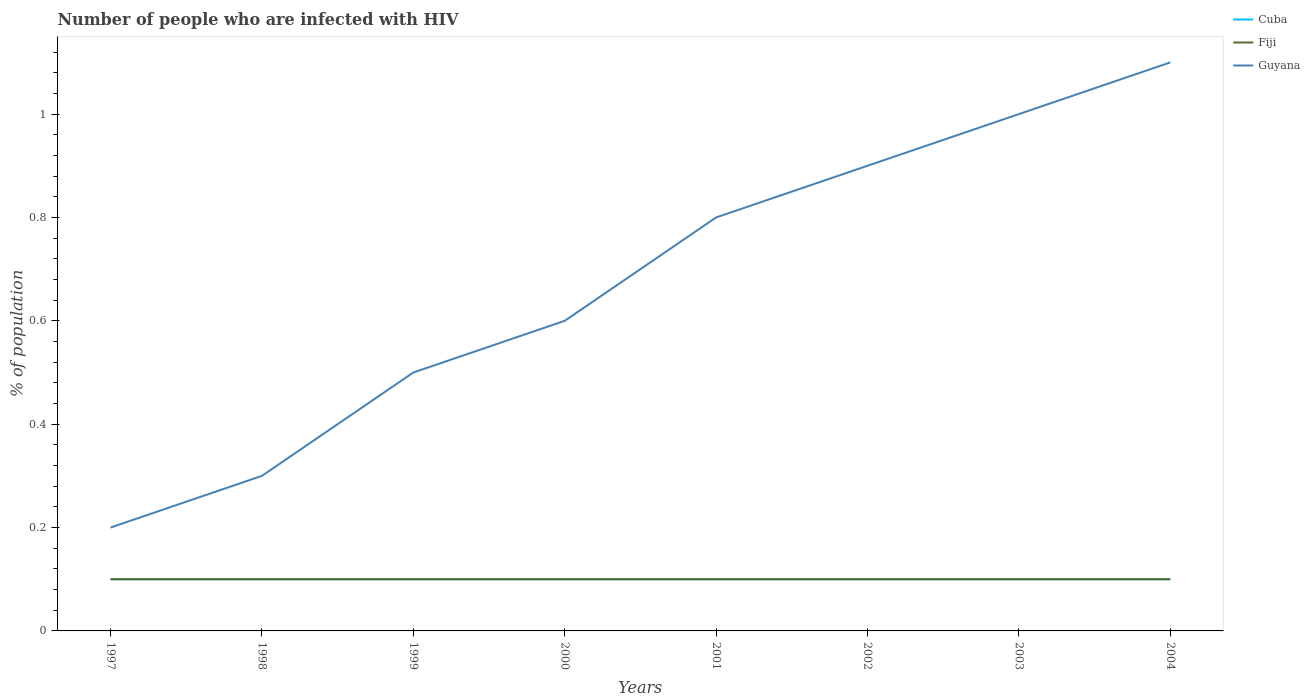How many different coloured lines are there?
Offer a very short reply. 3. Is the number of lines equal to the number of legend labels?
Provide a short and direct response. Yes. In which year was the percentage of HIV infected population in in Cuba maximum?
Ensure brevity in your answer.  1997. What is the difference between the highest and the second highest percentage of HIV infected population in in Guyana?
Ensure brevity in your answer.  0.9. What is the difference between the highest and the lowest percentage of HIV infected population in in Fiji?
Your answer should be very brief. 0. Is the percentage of HIV infected population in in Cuba strictly greater than the percentage of HIV infected population in in Fiji over the years?
Your answer should be very brief. No. Does the graph contain grids?
Offer a very short reply. No. Where does the legend appear in the graph?
Your answer should be compact. Top right. How many legend labels are there?
Your answer should be very brief. 3. How are the legend labels stacked?
Give a very brief answer. Vertical. What is the title of the graph?
Offer a terse response. Number of people who are infected with HIV. What is the label or title of the X-axis?
Keep it short and to the point. Years. What is the label or title of the Y-axis?
Make the answer very short. % of population. What is the % of population in Guyana in 1997?
Ensure brevity in your answer.  0.2. What is the % of population of Cuba in 1998?
Offer a terse response. 0.1. What is the % of population of Fiji in 1998?
Offer a very short reply. 0.1. What is the % of population of Guyana in 1998?
Give a very brief answer. 0.3. What is the % of population of Cuba in 2000?
Provide a succinct answer. 0.1. What is the % of population of Guyana in 2000?
Your answer should be very brief. 0.6. What is the % of population of Guyana in 2001?
Ensure brevity in your answer.  0.8. What is the % of population in Cuba in 2003?
Keep it short and to the point. 0.1. What is the % of population in Fiji in 2003?
Offer a very short reply. 0.1. What is the % of population in Guyana in 2003?
Your answer should be compact. 1. Across all years, what is the maximum % of population of Cuba?
Offer a terse response. 0.1. Across all years, what is the maximum % of population in Fiji?
Keep it short and to the point. 0.1. Across all years, what is the maximum % of population in Guyana?
Make the answer very short. 1.1. Across all years, what is the minimum % of population of Cuba?
Offer a terse response. 0.1. Across all years, what is the minimum % of population of Fiji?
Ensure brevity in your answer.  0.1. What is the total % of population in Cuba in the graph?
Offer a terse response. 0.8. What is the total % of population of Guyana in the graph?
Provide a short and direct response. 5.4. What is the difference between the % of population in Cuba in 1997 and that in 1998?
Your response must be concise. 0. What is the difference between the % of population of Guyana in 1997 and that in 1998?
Your answer should be very brief. -0.1. What is the difference between the % of population in Cuba in 1997 and that in 1999?
Give a very brief answer. 0. What is the difference between the % of population of Fiji in 1997 and that in 1999?
Keep it short and to the point. 0. What is the difference between the % of population of Guyana in 1997 and that in 1999?
Keep it short and to the point. -0.3. What is the difference between the % of population in Guyana in 1997 and that in 2000?
Your answer should be compact. -0.4. What is the difference between the % of population of Cuba in 1997 and that in 2001?
Give a very brief answer. 0. What is the difference between the % of population of Guyana in 1997 and that in 2001?
Provide a succinct answer. -0.6. What is the difference between the % of population of Cuba in 1997 and that in 2002?
Provide a short and direct response. 0. What is the difference between the % of population of Guyana in 1997 and that in 2002?
Your response must be concise. -0.7. What is the difference between the % of population of Cuba in 1997 and that in 2003?
Offer a terse response. 0. What is the difference between the % of population in Cuba in 1997 and that in 2004?
Your answer should be very brief. 0. What is the difference between the % of population in Fiji in 1997 and that in 2004?
Make the answer very short. 0. What is the difference between the % of population in Guyana in 1997 and that in 2004?
Make the answer very short. -0.9. What is the difference between the % of population in Fiji in 1998 and that in 1999?
Ensure brevity in your answer.  0. What is the difference between the % of population of Guyana in 1998 and that in 1999?
Offer a very short reply. -0.2. What is the difference between the % of population in Cuba in 1998 and that in 2000?
Your response must be concise. 0. What is the difference between the % of population in Fiji in 1998 and that in 2000?
Make the answer very short. 0. What is the difference between the % of population in Fiji in 1998 and that in 2001?
Keep it short and to the point. 0. What is the difference between the % of population in Guyana in 1998 and that in 2001?
Your response must be concise. -0.5. What is the difference between the % of population in Guyana in 1998 and that in 2002?
Your response must be concise. -0.6. What is the difference between the % of population of Cuba in 1998 and that in 2003?
Make the answer very short. 0. What is the difference between the % of population of Fiji in 1998 and that in 2003?
Provide a succinct answer. 0. What is the difference between the % of population of Guyana in 1998 and that in 2003?
Give a very brief answer. -0.7. What is the difference between the % of population in Cuba in 1998 and that in 2004?
Offer a terse response. 0. What is the difference between the % of population of Fiji in 1998 and that in 2004?
Offer a very short reply. 0. What is the difference between the % of population in Guyana in 1998 and that in 2004?
Your answer should be compact. -0.8. What is the difference between the % of population in Guyana in 1999 and that in 2001?
Give a very brief answer. -0.3. What is the difference between the % of population in Guyana in 1999 and that in 2002?
Provide a succinct answer. -0.4. What is the difference between the % of population in Cuba in 1999 and that in 2003?
Make the answer very short. 0. What is the difference between the % of population in Fiji in 1999 and that in 2003?
Offer a terse response. 0. What is the difference between the % of population in Guyana in 1999 and that in 2003?
Provide a succinct answer. -0.5. What is the difference between the % of population of Guyana in 1999 and that in 2004?
Your answer should be compact. -0.6. What is the difference between the % of population in Cuba in 2000 and that in 2001?
Provide a succinct answer. 0. What is the difference between the % of population in Fiji in 2000 and that in 2001?
Ensure brevity in your answer.  0. What is the difference between the % of population of Fiji in 2000 and that in 2002?
Offer a very short reply. 0. What is the difference between the % of population in Guyana in 2000 and that in 2002?
Provide a short and direct response. -0.3. What is the difference between the % of population in Guyana in 2000 and that in 2003?
Keep it short and to the point. -0.4. What is the difference between the % of population of Fiji in 2000 and that in 2004?
Make the answer very short. 0. What is the difference between the % of population of Guyana in 2000 and that in 2004?
Make the answer very short. -0.5. What is the difference between the % of population in Cuba in 2001 and that in 2002?
Your answer should be compact. 0. What is the difference between the % of population in Cuba in 2001 and that in 2003?
Your response must be concise. 0. What is the difference between the % of population in Fiji in 2001 and that in 2003?
Your answer should be very brief. 0. What is the difference between the % of population in Guyana in 2001 and that in 2003?
Offer a very short reply. -0.2. What is the difference between the % of population in Cuba in 2001 and that in 2004?
Your answer should be compact. 0. What is the difference between the % of population of Guyana in 2001 and that in 2004?
Your response must be concise. -0.3. What is the difference between the % of population in Cuba in 2002 and that in 2003?
Provide a succinct answer. 0. What is the difference between the % of population in Guyana in 2002 and that in 2003?
Provide a short and direct response. -0.1. What is the difference between the % of population in Cuba in 2003 and that in 2004?
Provide a succinct answer. 0. What is the difference between the % of population in Fiji in 2003 and that in 2004?
Offer a very short reply. 0. What is the difference between the % of population of Fiji in 1997 and the % of population of Guyana in 1998?
Provide a short and direct response. -0.2. What is the difference between the % of population in Cuba in 1997 and the % of population in Guyana in 1999?
Your answer should be very brief. -0.4. What is the difference between the % of population in Cuba in 1997 and the % of population in Fiji in 2000?
Your response must be concise. 0. What is the difference between the % of population of Cuba in 1997 and the % of population of Guyana in 2000?
Offer a very short reply. -0.5. What is the difference between the % of population of Fiji in 1997 and the % of population of Guyana in 2000?
Offer a very short reply. -0.5. What is the difference between the % of population of Fiji in 1997 and the % of population of Guyana in 2001?
Your answer should be compact. -0.7. What is the difference between the % of population in Cuba in 1997 and the % of population in Fiji in 2002?
Provide a succinct answer. 0. What is the difference between the % of population of Cuba in 1997 and the % of population of Guyana in 2002?
Provide a short and direct response. -0.8. What is the difference between the % of population of Fiji in 1997 and the % of population of Guyana in 2002?
Offer a terse response. -0.8. What is the difference between the % of population of Cuba in 1997 and the % of population of Guyana in 2003?
Keep it short and to the point. -0.9. What is the difference between the % of population in Cuba in 1997 and the % of population in Fiji in 2004?
Offer a very short reply. 0. What is the difference between the % of population in Cuba in 1997 and the % of population in Guyana in 2004?
Offer a terse response. -1. What is the difference between the % of population in Fiji in 1997 and the % of population in Guyana in 2004?
Your answer should be very brief. -1. What is the difference between the % of population of Cuba in 1998 and the % of population of Fiji in 1999?
Your answer should be compact. 0. What is the difference between the % of population of Cuba in 1998 and the % of population of Guyana in 1999?
Ensure brevity in your answer.  -0.4. What is the difference between the % of population of Cuba in 1998 and the % of population of Guyana in 2000?
Keep it short and to the point. -0.5. What is the difference between the % of population of Cuba in 1998 and the % of population of Fiji in 2001?
Ensure brevity in your answer.  0. What is the difference between the % of population in Cuba in 1998 and the % of population in Guyana in 2001?
Your answer should be compact. -0.7. What is the difference between the % of population in Cuba in 1998 and the % of population in Fiji in 2002?
Ensure brevity in your answer.  0. What is the difference between the % of population of Cuba in 1998 and the % of population of Fiji in 2003?
Provide a succinct answer. 0. What is the difference between the % of population in Cuba in 1998 and the % of population in Guyana in 2003?
Offer a very short reply. -0.9. What is the difference between the % of population of Fiji in 1998 and the % of population of Guyana in 2003?
Your answer should be very brief. -0.9. What is the difference between the % of population of Cuba in 1998 and the % of population of Guyana in 2004?
Give a very brief answer. -1. What is the difference between the % of population of Fiji in 1998 and the % of population of Guyana in 2004?
Ensure brevity in your answer.  -1. What is the difference between the % of population of Fiji in 1999 and the % of population of Guyana in 2000?
Your answer should be very brief. -0.5. What is the difference between the % of population in Fiji in 1999 and the % of population in Guyana in 2001?
Give a very brief answer. -0.7. What is the difference between the % of population in Cuba in 1999 and the % of population in Guyana in 2002?
Make the answer very short. -0.8. What is the difference between the % of population of Fiji in 1999 and the % of population of Guyana in 2002?
Make the answer very short. -0.8. What is the difference between the % of population of Cuba in 1999 and the % of population of Fiji in 2003?
Your response must be concise. 0. What is the difference between the % of population of Cuba in 1999 and the % of population of Guyana in 2003?
Offer a very short reply. -0.9. What is the difference between the % of population of Fiji in 1999 and the % of population of Guyana in 2003?
Keep it short and to the point. -0.9. What is the difference between the % of population of Cuba in 1999 and the % of population of Fiji in 2004?
Your answer should be very brief. 0. What is the difference between the % of population in Cuba in 1999 and the % of population in Guyana in 2004?
Ensure brevity in your answer.  -1. What is the difference between the % of population in Cuba in 2000 and the % of population in Fiji in 2001?
Ensure brevity in your answer.  0. What is the difference between the % of population of Fiji in 2000 and the % of population of Guyana in 2001?
Your answer should be compact. -0.7. What is the difference between the % of population of Fiji in 2000 and the % of population of Guyana in 2002?
Keep it short and to the point. -0.8. What is the difference between the % of population of Cuba in 2000 and the % of population of Fiji in 2003?
Your answer should be very brief. 0. What is the difference between the % of population of Fiji in 2000 and the % of population of Guyana in 2003?
Ensure brevity in your answer.  -0.9. What is the difference between the % of population in Fiji in 2000 and the % of population in Guyana in 2004?
Give a very brief answer. -1. What is the difference between the % of population in Cuba in 2001 and the % of population in Fiji in 2002?
Give a very brief answer. 0. What is the difference between the % of population in Cuba in 2001 and the % of population in Guyana in 2002?
Offer a very short reply. -0.8. What is the difference between the % of population of Fiji in 2001 and the % of population of Guyana in 2002?
Make the answer very short. -0.8. What is the difference between the % of population in Cuba in 2001 and the % of population in Fiji in 2003?
Ensure brevity in your answer.  0. What is the difference between the % of population of Fiji in 2001 and the % of population of Guyana in 2003?
Provide a short and direct response. -0.9. What is the difference between the % of population of Cuba in 2001 and the % of population of Guyana in 2004?
Offer a very short reply. -1. What is the difference between the % of population in Cuba in 2002 and the % of population in Guyana in 2003?
Your answer should be compact. -0.9. What is the difference between the % of population in Fiji in 2002 and the % of population in Guyana in 2003?
Make the answer very short. -0.9. What is the difference between the % of population in Cuba in 2002 and the % of population in Guyana in 2004?
Give a very brief answer. -1. What is the difference between the % of population in Cuba in 2003 and the % of population in Guyana in 2004?
Provide a short and direct response. -1. What is the difference between the % of population of Fiji in 2003 and the % of population of Guyana in 2004?
Provide a succinct answer. -1. What is the average % of population of Cuba per year?
Offer a very short reply. 0.1. What is the average % of population in Guyana per year?
Your response must be concise. 0.68. In the year 1997, what is the difference between the % of population of Cuba and % of population of Fiji?
Provide a succinct answer. 0. In the year 1997, what is the difference between the % of population in Fiji and % of population in Guyana?
Provide a short and direct response. -0.1. In the year 1998, what is the difference between the % of population of Cuba and % of population of Fiji?
Offer a terse response. 0. In the year 1998, what is the difference between the % of population in Fiji and % of population in Guyana?
Give a very brief answer. -0.2. In the year 2000, what is the difference between the % of population of Cuba and % of population of Guyana?
Your answer should be very brief. -0.5. In the year 2000, what is the difference between the % of population of Fiji and % of population of Guyana?
Offer a very short reply. -0.5. In the year 2001, what is the difference between the % of population in Cuba and % of population in Guyana?
Ensure brevity in your answer.  -0.7. In the year 2002, what is the difference between the % of population of Cuba and % of population of Fiji?
Your response must be concise. 0. In the year 2002, what is the difference between the % of population of Cuba and % of population of Guyana?
Your response must be concise. -0.8. In the year 2002, what is the difference between the % of population of Fiji and % of population of Guyana?
Offer a very short reply. -0.8. In the year 2003, what is the difference between the % of population in Cuba and % of population in Fiji?
Keep it short and to the point. 0. In the year 2003, what is the difference between the % of population in Fiji and % of population in Guyana?
Make the answer very short. -0.9. What is the ratio of the % of population in Cuba in 1997 to that in 1999?
Provide a short and direct response. 1. What is the ratio of the % of population of Fiji in 1997 to that in 1999?
Make the answer very short. 1. What is the ratio of the % of population in Cuba in 1997 to that in 2000?
Make the answer very short. 1. What is the ratio of the % of population of Fiji in 1997 to that in 2001?
Your response must be concise. 1. What is the ratio of the % of population in Guyana in 1997 to that in 2002?
Provide a short and direct response. 0.22. What is the ratio of the % of population of Fiji in 1997 to that in 2003?
Keep it short and to the point. 1. What is the ratio of the % of population in Guyana in 1997 to that in 2003?
Your answer should be compact. 0.2. What is the ratio of the % of population of Cuba in 1997 to that in 2004?
Give a very brief answer. 1. What is the ratio of the % of population in Fiji in 1997 to that in 2004?
Offer a very short reply. 1. What is the ratio of the % of population of Guyana in 1997 to that in 2004?
Offer a very short reply. 0.18. What is the ratio of the % of population of Cuba in 1998 to that in 1999?
Your answer should be very brief. 1. What is the ratio of the % of population of Cuba in 1998 to that in 2000?
Ensure brevity in your answer.  1. What is the ratio of the % of population of Guyana in 1998 to that in 2001?
Your answer should be compact. 0.38. What is the ratio of the % of population in Cuba in 1998 to that in 2002?
Provide a succinct answer. 1. What is the ratio of the % of population in Fiji in 1998 to that in 2002?
Your response must be concise. 1. What is the ratio of the % of population of Fiji in 1998 to that in 2003?
Make the answer very short. 1. What is the ratio of the % of population of Guyana in 1998 to that in 2003?
Your answer should be very brief. 0.3. What is the ratio of the % of population of Fiji in 1998 to that in 2004?
Give a very brief answer. 1. What is the ratio of the % of population in Guyana in 1998 to that in 2004?
Give a very brief answer. 0.27. What is the ratio of the % of population of Fiji in 1999 to that in 2000?
Your answer should be compact. 1. What is the ratio of the % of population of Cuba in 1999 to that in 2001?
Your answer should be compact. 1. What is the ratio of the % of population in Guyana in 1999 to that in 2002?
Your response must be concise. 0.56. What is the ratio of the % of population in Guyana in 1999 to that in 2003?
Your answer should be compact. 0.5. What is the ratio of the % of population in Fiji in 1999 to that in 2004?
Make the answer very short. 1. What is the ratio of the % of population of Guyana in 1999 to that in 2004?
Ensure brevity in your answer.  0.45. What is the ratio of the % of population in Fiji in 2000 to that in 2001?
Make the answer very short. 1. What is the ratio of the % of population in Guyana in 2000 to that in 2001?
Give a very brief answer. 0.75. What is the ratio of the % of population of Cuba in 2000 to that in 2002?
Offer a terse response. 1. What is the ratio of the % of population in Fiji in 2000 to that in 2002?
Offer a very short reply. 1. What is the ratio of the % of population in Cuba in 2000 to that in 2003?
Offer a terse response. 1. What is the ratio of the % of population of Fiji in 2000 to that in 2003?
Give a very brief answer. 1. What is the ratio of the % of population of Guyana in 2000 to that in 2003?
Make the answer very short. 0.6. What is the ratio of the % of population of Cuba in 2000 to that in 2004?
Provide a succinct answer. 1. What is the ratio of the % of population of Guyana in 2000 to that in 2004?
Offer a terse response. 0.55. What is the ratio of the % of population in Guyana in 2001 to that in 2002?
Provide a succinct answer. 0.89. What is the ratio of the % of population in Fiji in 2001 to that in 2003?
Make the answer very short. 1. What is the ratio of the % of population of Cuba in 2001 to that in 2004?
Keep it short and to the point. 1. What is the ratio of the % of population in Fiji in 2001 to that in 2004?
Make the answer very short. 1. What is the ratio of the % of population of Guyana in 2001 to that in 2004?
Your answer should be very brief. 0.73. What is the ratio of the % of population in Fiji in 2002 to that in 2003?
Provide a short and direct response. 1. What is the ratio of the % of population of Guyana in 2002 to that in 2003?
Provide a short and direct response. 0.9. What is the ratio of the % of population of Cuba in 2002 to that in 2004?
Offer a very short reply. 1. What is the ratio of the % of population of Fiji in 2002 to that in 2004?
Your response must be concise. 1. What is the ratio of the % of population of Guyana in 2002 to that in 2004?
Make the answer very short. 0.82. What is the ratio of the % of population in Cuba in 2003 to that in 2004?
Your answer should be compact. 1. What is the ratio of the % of population in Fiji in 2003 to that in 2004?
Give a very brief answer. 1. What is the difference between the highest and the second highest % of population of Fiji?
Give a very brief answer. 0. What is the difference between the highest and the second highest % of population in Guyana?
Your response must be concise. 0.1. What is the difference between the highest and the lowest % of population in Guyana?
Provide a succinct answer. 0.9. 